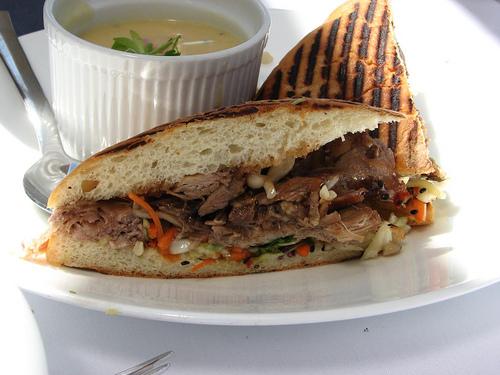What utensil is on the plate?
Be succinct. Spoon. What other food besides a sandwich is shown?
Concise answer only. Soup. What is the side of this sandwich?
Short answer required. Soup. Is there bacon on the sandwich?
Concise answer only. No. What kind of meat is on the sandwich?
Short answer required. Beef. 